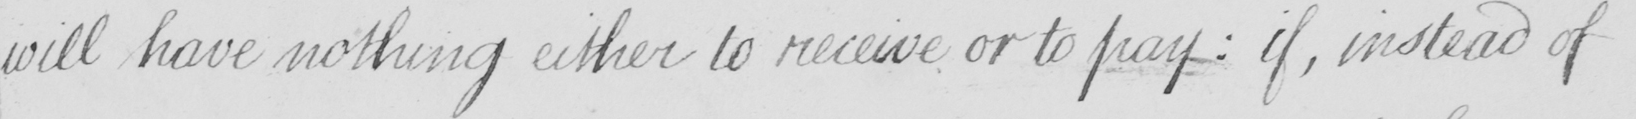What does this handwritten line say? will have nothing either to receive or to pay :  if , instead of 